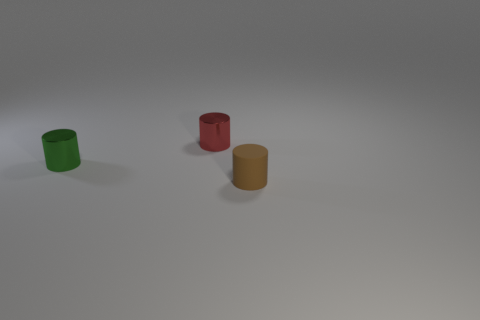There is a metal cylinder in front of the red metallic cylinder; does it have the same size as the metallic thing that is right of the tiny green metallic object?
Your response must be concise. Yes. Are there more small brown matte things that are behind the small brown thing than red objects that are in front of the red thing?
Your answer should be compact. No. Is there a big green sphere made of the same material as the tiny red object?
Provide a short and direct response. No. There is a cylinder that is both on the right side of the green thing and in front of the tiny red cylinder; what material is it made of?
Your answer should be compact. Rubber. What is the color of the tiny matte cylinder?
Offer a terse response. Brown. What number of other red metal objects have the same shape as the small red metal thing?
Your response must be concise. 0. Do the brown thing that is in front of the tiny green shiny thing and the small object that is behind the small green cylinder have the same material?
Your answer should be very brief. No. How big is the object behind the shiny thing that is in front of the red shiny object?
Keep it short and to the point. Small. Is there any other thing that has the same size as the brown cylinder?
Ensure brevity in your answer.  Yes. There is a tiny green object that is the same shape as the tiny red metal thing; what is its material?
Offer a very short reply. Metal. 